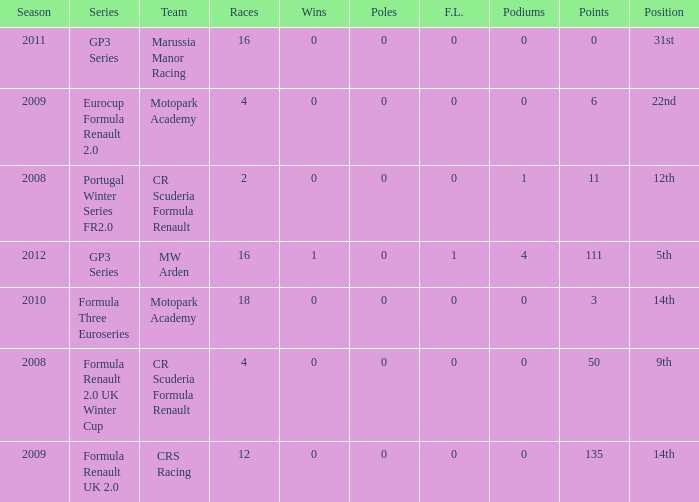What are the most poles listed? 0.0. 